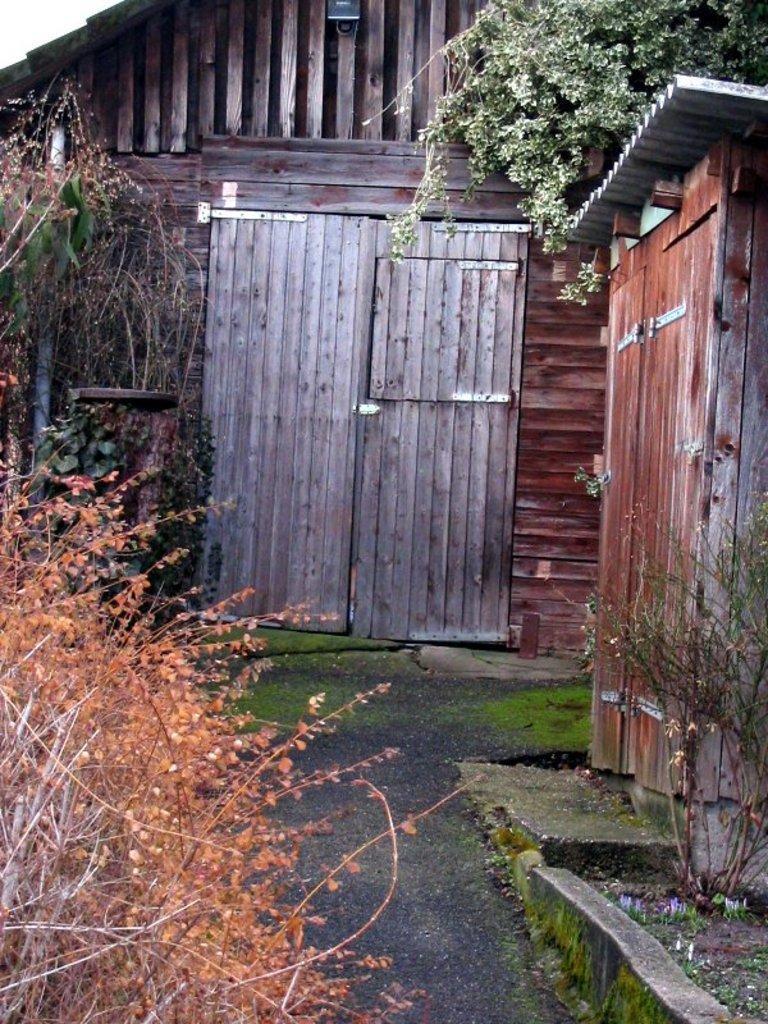Please provide a concise description of this image. At the bottom of the picture, we see the road. On the left side, there are trees. On the right side, we see a plant and a wooden shed. In the background, we see a building and a grey door. At the top, we see the tree. 